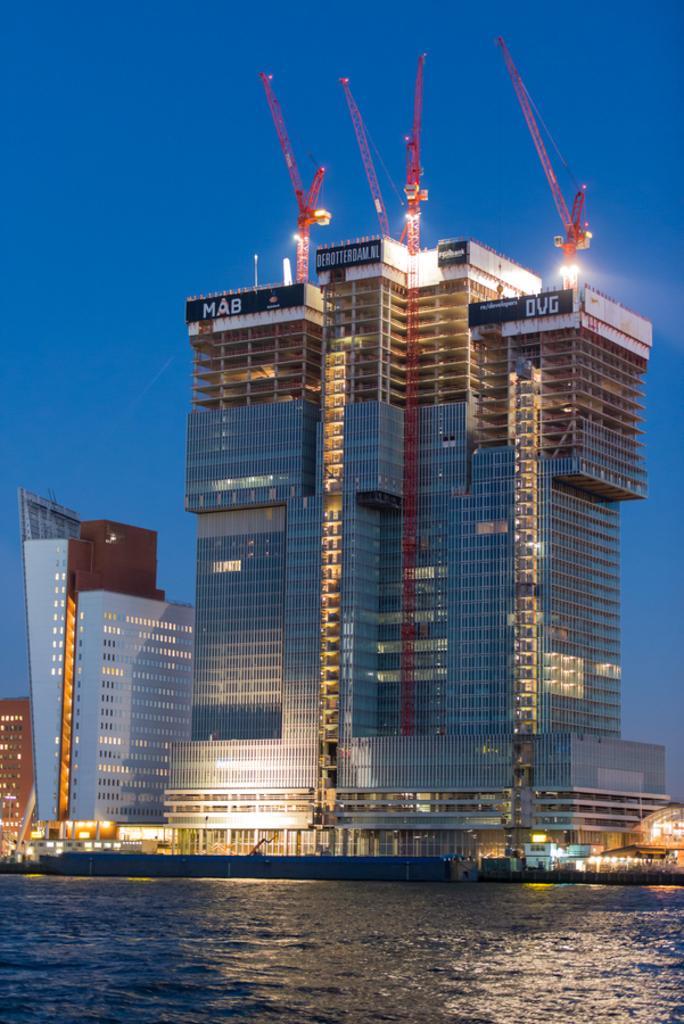Could you give a brief overview of what you see in this image? In this image there is water at the bottom. In the middle there is a tall building which is under construction. At the top there is the sky. On the left side bottom there is another building in which there are lights. We can see that there are cranes at the top. 